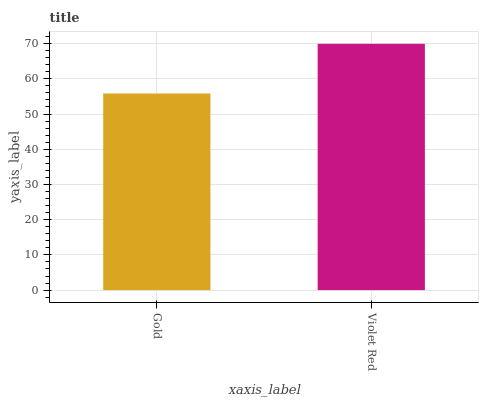Is Gold the minimum?
Answer yes or no. Yes. Is Violet Red the maximum?
Answer yes or no. Yes. Is Violet Red the minimum?
Answer yes or no. No. Is Violet Red greater than Gold?
Answer yes or no. Yes. Is Gold less than Violet Red?
Answer yes or no. Yes. Is Gold greater than Violet Red?
Answer yes or no. No. Is Violet Red less than Gold?
Answer yes or no. No. Is Violet Red the high median?
Answer yes or no. Yes. Is Gold the low median?
Answer yes or no. Yes. Is Gold the high median?
Answer yes or no. No. Is Violet Red the low median?
Answer yes or no. No. 